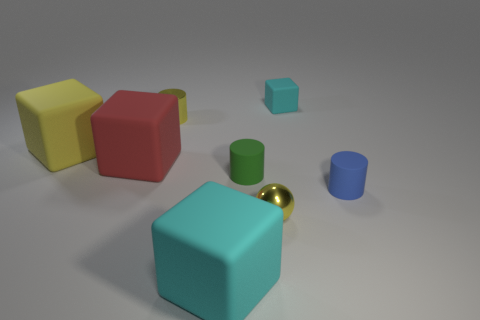Subtract all small rubber cylinders. How many cylinders are left? 1 Add 1 tiny cyan matte things. How many objects exist? 9 Subtract all blue cylinders. How many cyan cubes are left? 2 Subtract all green cylinders. How many cylinders are left? 2 Subtract 3 cubes. How many cubes are left? 1 Subtract all large red objects. Subtract all cyan blocks. How many objects are left? 5 Add 8 blue things. How many blue things are left? 9 Add 4 tiny cyan rubber things. How many tiny cyan rubber things exist? 5 Subtract 0 blue blocks. How many objects are left? 8 Subtract all cylinders. How many objects are left? 5 